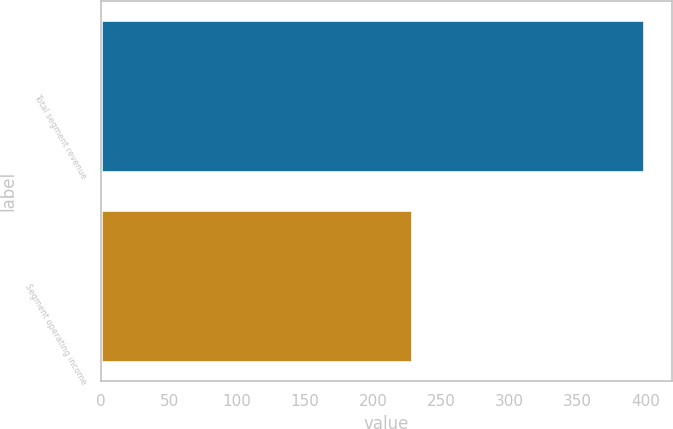Convert chart to OTSL. <chart><loc_0><loc_0><loc_500><loc_500><bar_chart><fcel>Total segment revenue<fcel>Segment operating income<nl><fcel>399<fcel>228<nl></chart> 